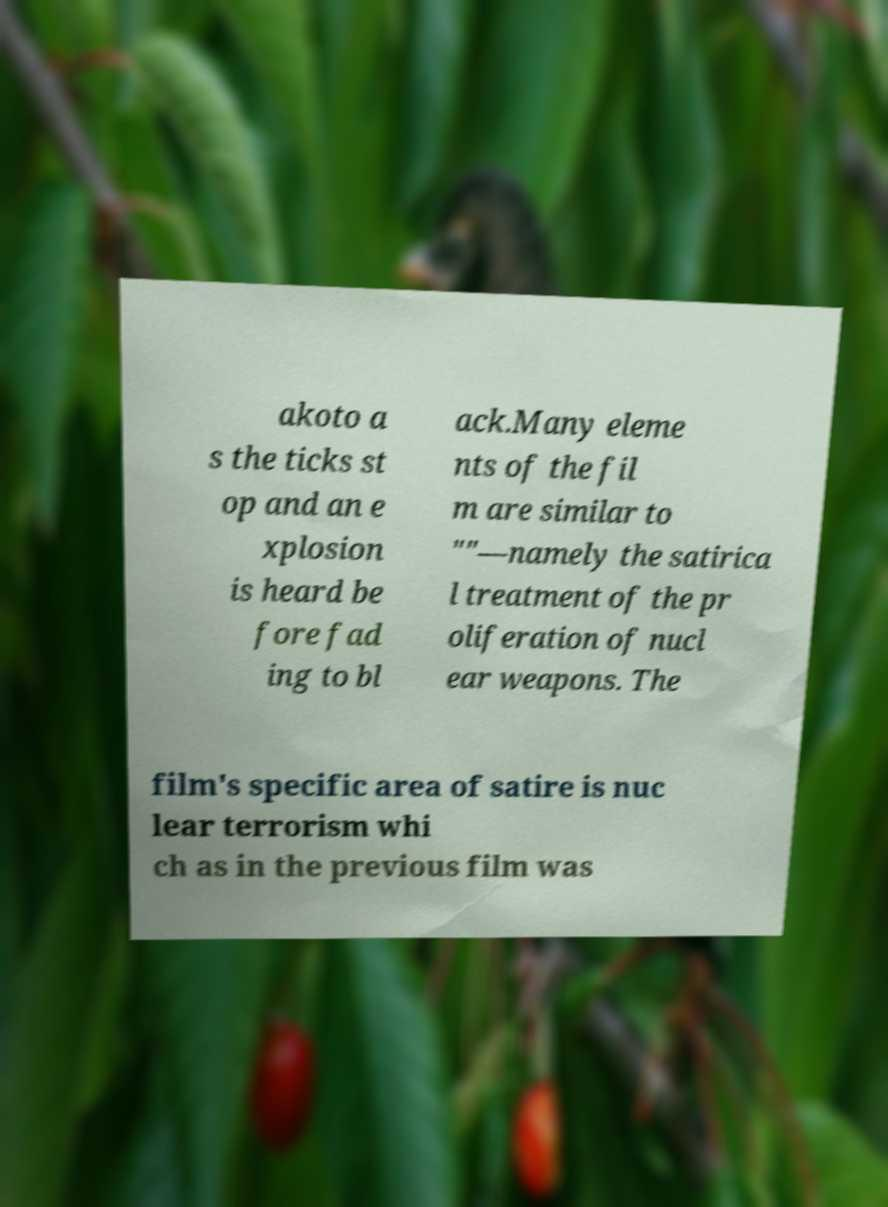I need the written content from this picture converted into text. Can you do that? akoto a s the ticks st op and an e xplosion is heard be fore fad ing to bl ack.Many eleme nts of the fil m are similar to ""—namely the satirica l treatment of the pr oliferation of nucl ear weapons. The film's specific area of satire is nuc lear terrorism whi ch as in the previous film was 